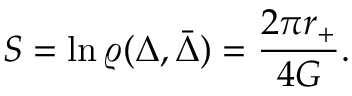<formula> <loc_0><loc_0><loc_500><loc_500>S = \ln \varrho ( \Delta , \bar { \Delta } ) = { \frac { 2 \pi r _ { + } } { 4 G } } .</formula> 